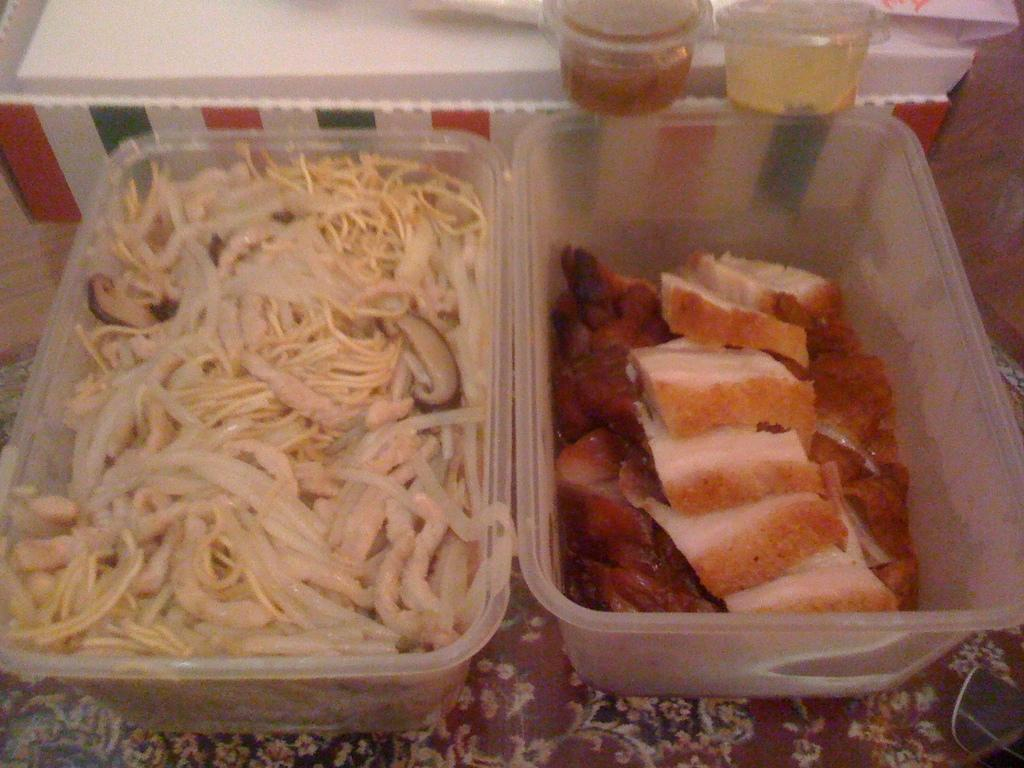What is present on the table in the image? There is a table in the image, and there are trays on the table. What is inside the trays on the table? There is a food item in the trays. How much profit can be made from the grapes in the image? There are no grapes present in the image, so it is not possible to determine the profit from them. 